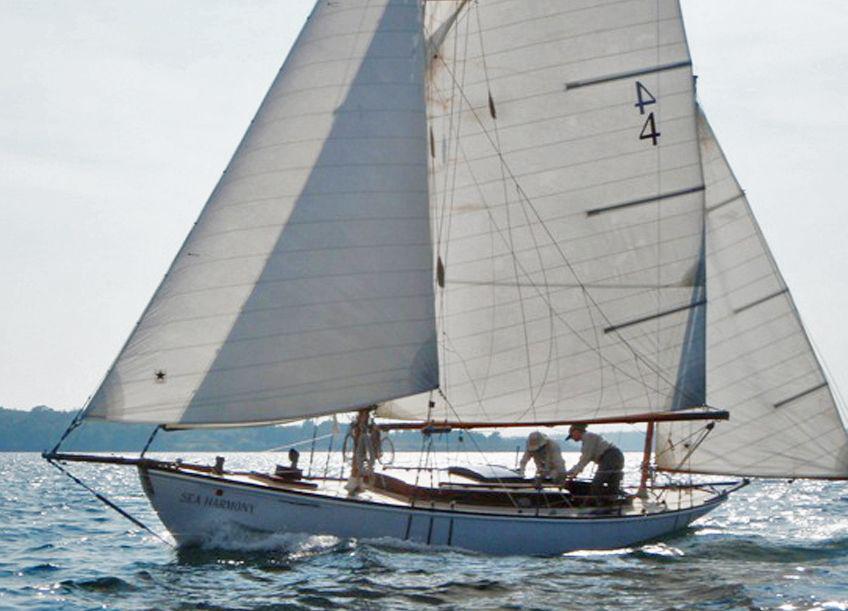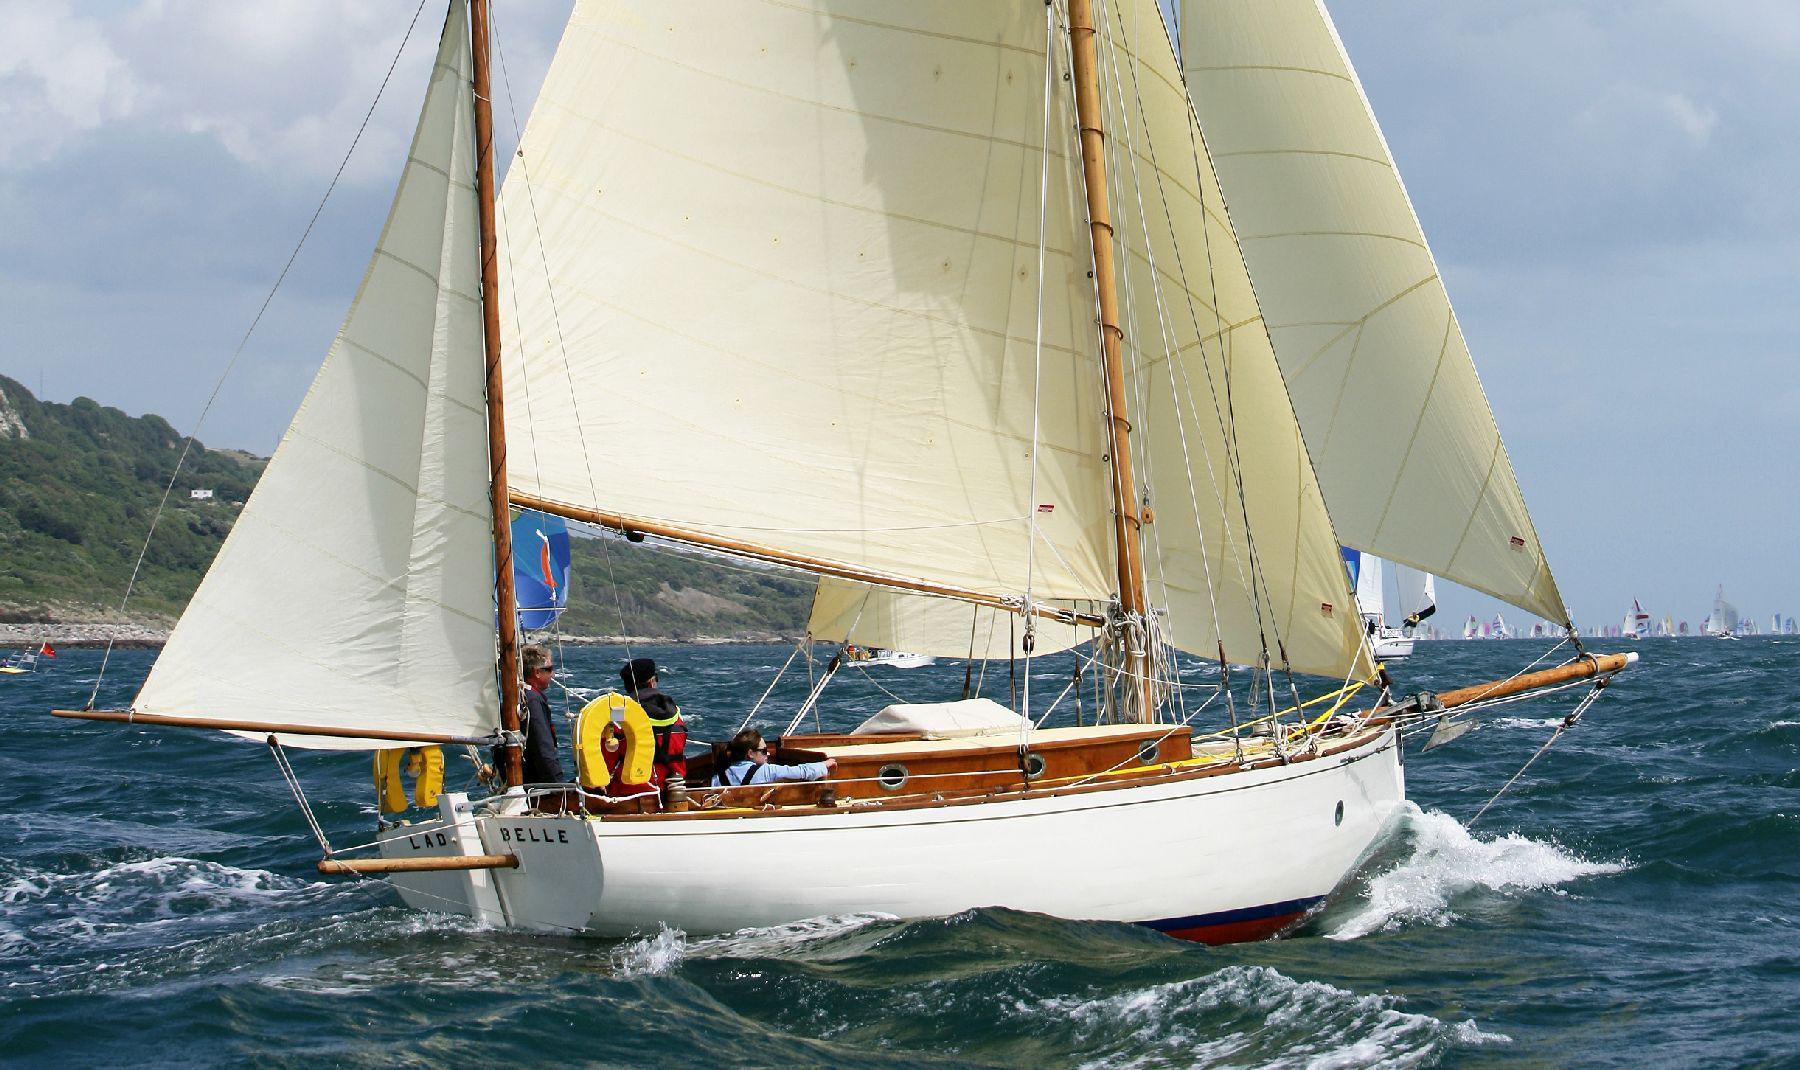The first image is the image on the left, the second image is the image on the right. Examine the images to the left and right. Is the description "The left and right image contains the same number sailboats with at least one boat with its sails down." accurate? Answer yes or no. No. The first image is the image on the left, the second image is the image on the right. Evaluate the accuracy of this statement regarding the images: "The sails in the left image are closed.". Is it true? Answer yes or no. No. 